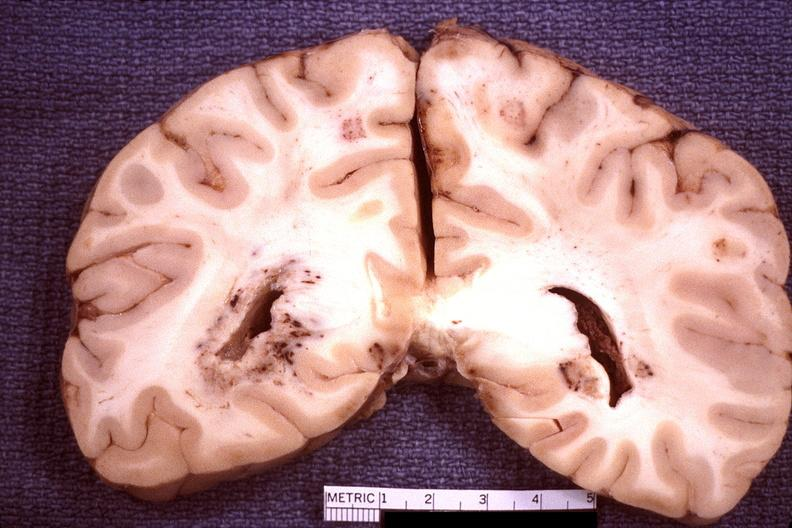what is present?
Answer the question using a single word or phrase. Nervous 